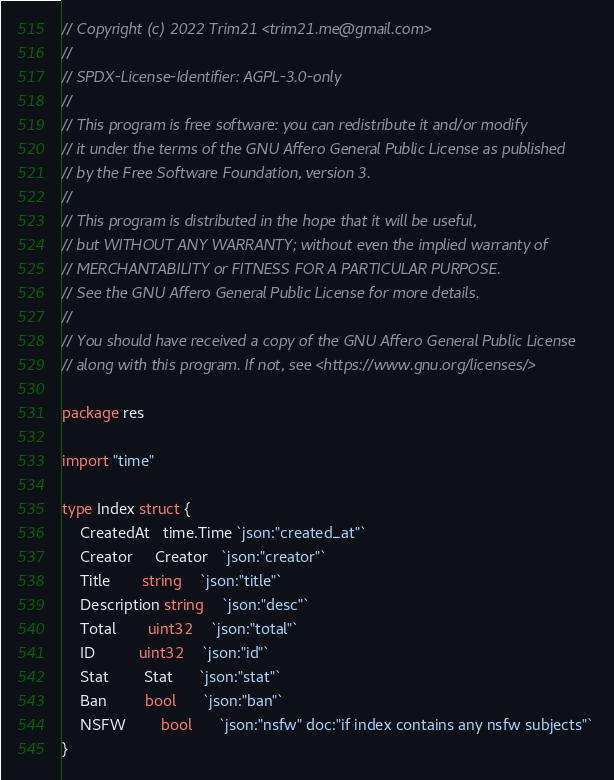<code> <loc_0><loc_0><loc_500><loc_500><_Go_>// Copyright (c) 2022 Trim21 <trim21.me@gmail.com>
//
// SPDX-License-Identifier: AGPL-3.0-only
//
// This program is free software: you can redistribute it and/or modify
// it under the terms of the GNU Affero General Public License as published
// by the Free Software Foundation, version 3.
//
// This program is distributed in the hope that it will be useful,
// but WITHOUT ANY WARRANTY; without even the implied warranty of
// MERCHANTABILITY or FITNESS FOR A PARTICULAR PURPOSE.
// See the GNU Affero General Public License for more details.
//
// You should have received a copy of the GNU Affero General Public License
// along with this program. If not, see <https://www.gnu.org/licenses/>

package res

import "time"

type Index struct {
	CreatedAt   time.Time `json:"created_at"`
	Creator     Creator   `json:"creator"`
	Title       string    `json:"title"`
	Description string    `json:"desc"`
	Total       uint32    `json:"total"`
	ID          uint32    `json:"id"`
	Stat        Stat      `json:"stat"`
	Ban         bool      `json:"ban"`
	NSFW        bool      `json:"nsfw" doc:"if index contains any nsfw subjects"`
}
</code> 